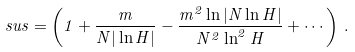<formula> <loc_0><loc_0><loc_500><loc_500>\ s u s = \left ( 1 + \frac { m } { N | \ln H | } - \frac { m ^ { 2 } \ln | N \ln H | } { N ^ { 2 } \ln ^ { 2 } H } + \cdots \, \right ) \, .</formula> 